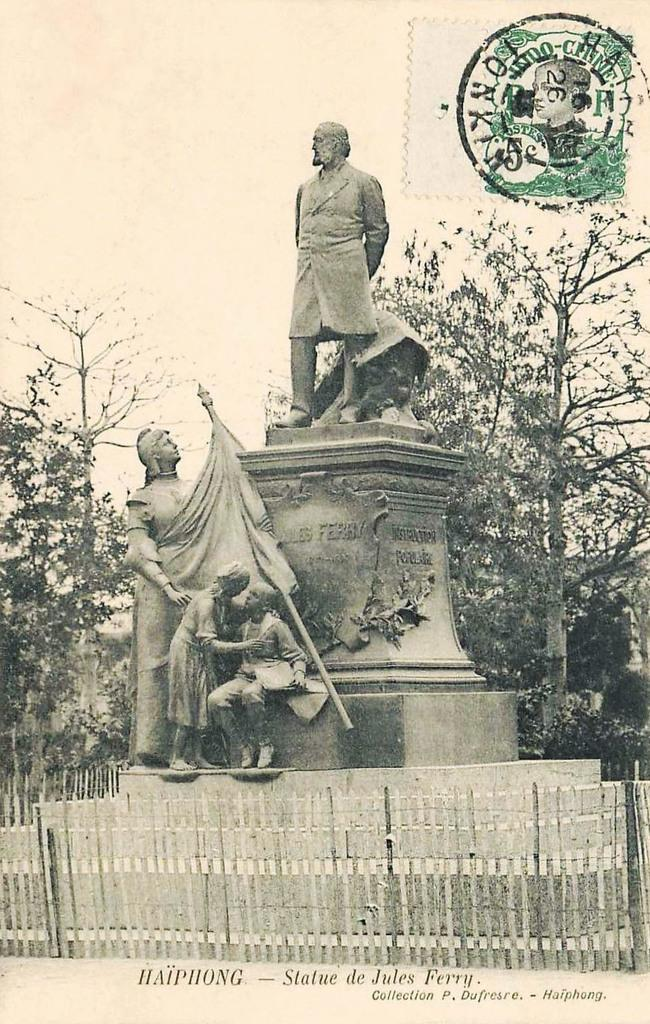What type of visual is the image? The image is a poster. What can be seen in the poster? There are statues, trees, and fencing in the image. Is there any text in the image? Yes, there is some text at the bottom of the image. Is there any additional design element in the image? Yes, there is a stamp at the top of the image. How many cobwebs can be seen in the image? There are no cobwebs present in the image. What type of wool is used to create the statues in the image? The statues in the image are not made of wool, and the material used to create them is not mentioned in the facts provided. 